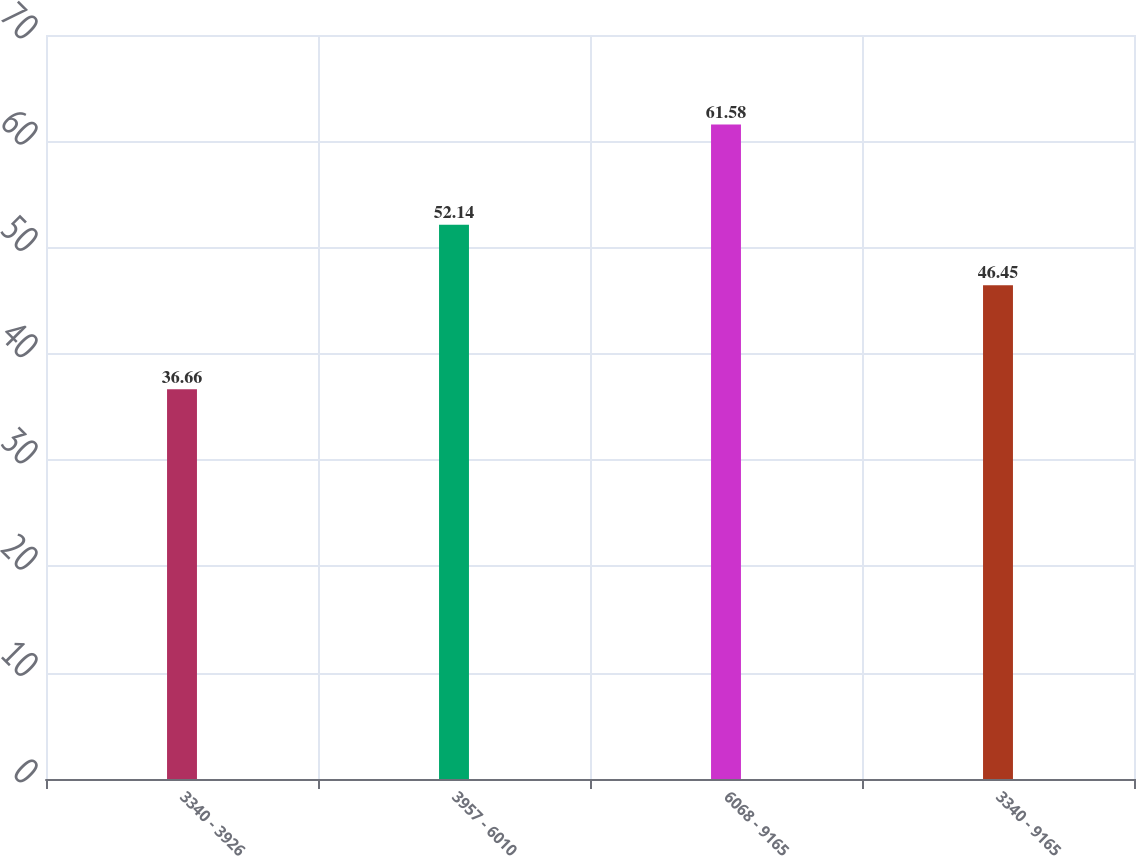<chart> <loc_0><loc_0><loc_500><loc_500><bar_chart><fcel>3340 - 3926<fcel>3957 - 6010<fcel>6068 - 9165<fcel>3340 - 9165<nl><fcel>36.66<fcel>52.14<fcel>61.58<fcel>46.45<nl></chart> 